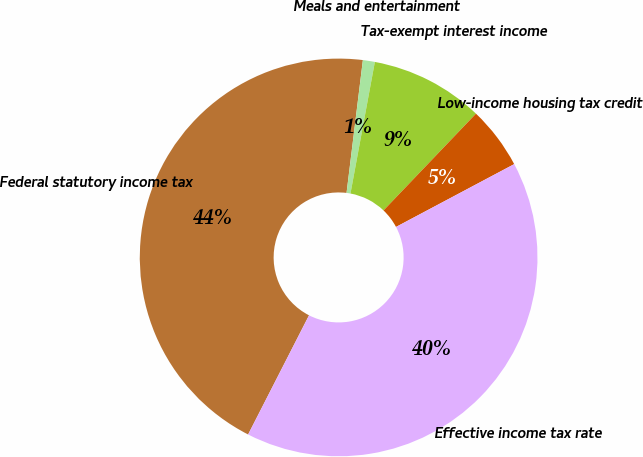<chart> <loc_0><loc_0><loc_500><loc_500><pie_chart><fcel>Federal statutory income tax<fcel>Meals and entertainment<fcel>Tax-exempt interest income<fcel>Low-income housing tax credit<fcel>Effective income tax rate<nl><fcel>44.43%<fcel>0.97%<fcel>9.22%<fcel>5.09%<fcel>40.3%<nl></chart> 